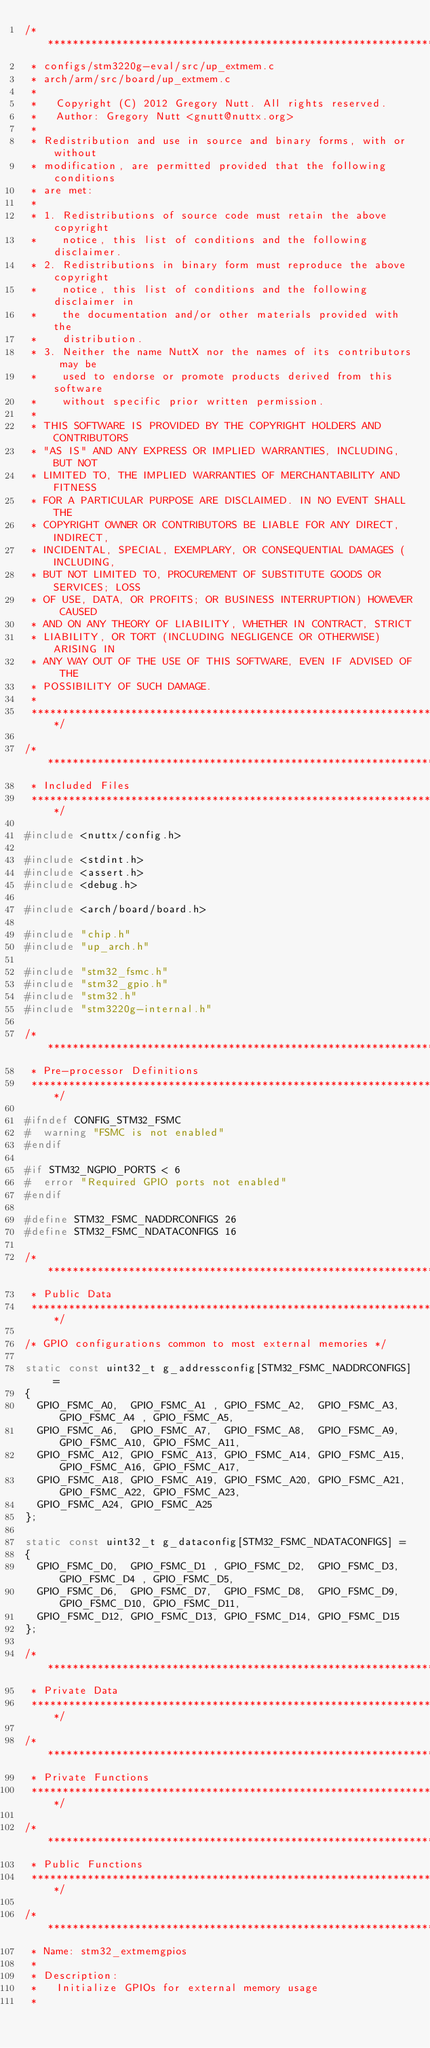Convert code to text. <code><loc_0><loc_0><loc_500><loc_500><_C_>/************************************************************************************
 * configs/stm3220g-eval/src/up_extmem.c
 * arch/arm/src/board/up_extmem.c
 *
 *   Copyright (C) 2012 Gregory Nutt. All rights reserved.
 *   Author: Gregory Nutt <gnutt@nuttx.org>
 *
 * Redistribution and use in source and binary forms, with or without
 * modification, are permitted provided that the following conditions
 * are met:
 *
 * 1. Redistributions of source code must retain the above copyright
 *    notice, this list of conditions and the following disclaimer.
 * 2. Redistributions in binary form must reproduce the above copyright
 *    notice, this list of conditions and the following disclaimer in
 *    the documentation and/or other materials provided with the
 *    distribution.
 * 3. Neither the name NuttX nor the names of its contributors may be
 *    used to endorse or promote products derived from this software
 *    without specific prior written permission.
 *
 * THIS SOFTWARE IS PROVIDED BY THE COPYRIGHT HOLDERS AND CONTRIBUTORS
 * "AS IS" AND ANY EXPRESS OR IMPLIED WARRANTIES, INCLUDING, BUT NOT
 * LIMITED TO, THE IMPLIED WARRANTIES OF MERCHANTABILITY AND FITNESS
 * FOR A PARTICULAR PURPOSE ARE DISCLAIMED. IN NO EVENT SHALL THE
 * COPYRIGHT OWNER OR CONTRIBUTORS BE LIABLE FOR ANY DIRECT, INDIRECT,
 * INCIDENTAL, SPECIAL, EXEMPLARY, OR CONSEQUENTIAL DAMAGES (INCLUDING,
 * BUT NOT LIMITED TO, PROCUREMENT OF SUBSTITUTE GOODS OR SERVICES; LOSS
 * OF USE, DATA, OR PROFITS; OR BUSINESS INTERRUPTION) HOWEVER CAUSED
 * AND ON ANY THEORY OF LIABILITY, WHETHER IN CONTRACT, STRICT
 * LIABILITY, OR TORT (INCLUDING NEGLIGENCE OR OTHERWISE) ARISING IN
 * ANY WAY OUT OF THE USE OF THIS SOFTWARE, EVEN IF ADVISED OF THE
 * POSSIBILITY OF SUCH DAMAGE.
 *
 ************************************************************************************/

/************************************************************************************
 * Included Files
 ************************************************************************************/

#include <nuttx/config.h>

#include <stdint.h>
#include <assert.h>
#include <debug.h>

#include <arch/board/board.h>

#include "chip.h"
#include "up_arch.h"

#include "stm32_fsmc.h"
#include "stm32_gpio.h"
#include "stm32.h"
#include "stm3220g-internal.h"

/************************************************************************************
 * Pre-processor Definitions
 ************************************************************************************/

#ifndef CONFIG_STM32_FSMC
#  warning "FSMC is not enabled"
#endif

#if STM32_NGPIO_PORTS < 6
#  error "Required GPIO ports not enabled"
#endif

#define STM32_FSMC_NADDRCONFIGS 26
#define STM32_FSMC_NDATACONFIGS 16

/************************************************************************************
 * Public Data
 ************************************************************************************/

/* GPIO configurations common to most external memories */

static const uint32_t g_addressconfig[STM32_FSMC_NADDRCONFIGS] =
{
  GPIO_FSMC_A0,  GPIO_FSMC_A1 , GPIO_FSMC_A2,  GPIO_FSMC_A3,  GPIO_FSMC_A4 , GPIO_FSMC_A5,
  GPIO_FSMC_A6,  GPIO_FSMC_A7,  GPIO_FSMC_A8,  GPIO_FSMC_A9,  GPIO_FSMC_A10, GPIO_FSMC_A11,
  GPIO_FSMC_A12, GPIO_FSMC_A13, GPIO_FSMC_A14, GPIO_FSMC_A15, GPIO_FSMC_A16, GPIO_FSMC_A17,
  GPIO_FSMC_A18, GPIO_FSMC_A19, GPIO_FSMC_A20, GPIO_FSMC_A21, GPIO_FSMC_A22, GPIO_FSMC_A23,
  GPIO_FSMC_A24, GPIO_FSMC_A25
};

static const uint32_t g_dataconfig[STM32_FSMC_NDATACONFIGS] =
{
  GPIO_FSMC_D0,  GPIO_FSMC_D1 , GPIO_FSMC_D2,  GPIO_FSMC_D3,  GPIO_FSMC_D4 , GPIO_FSMC_D5,
  GPIO_FSMC_D6,  GPIO_FSMC_D7,  GPIO_FSMC_D8,  GPIO_FSMC_D9,  GPIO_FSMC_D10, GPIO_FSMC_D11,
  GPIO_FSMC_D12, GPIO_FSMC_D13, GPIO_FSMC_D14, GPIO_FSMC_D15
};

/************************************************************************************
 * Private Data
 ************************************************************************************/

/************************************************************************************
 * Private Functions
 ************************************************************************************/

/************************************************************************************
 * Public Functions
 ************************************************************************************/

/************************************************************************************
 * Name: stm32_extmemgpios
 *
 * Description:
 *   Initialize GPIOs for external memory usage
 *</code> 